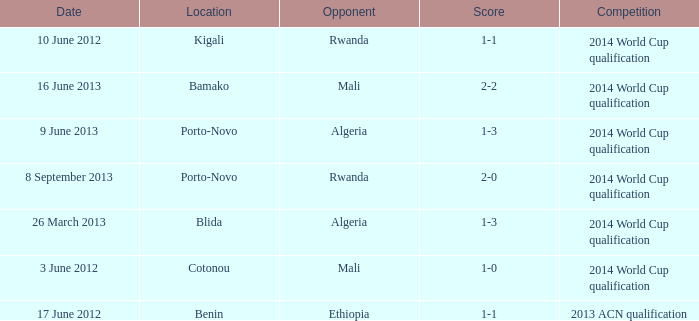What is the score from the game where Algeria is the opponent at Porto-Novo? 1-3. 